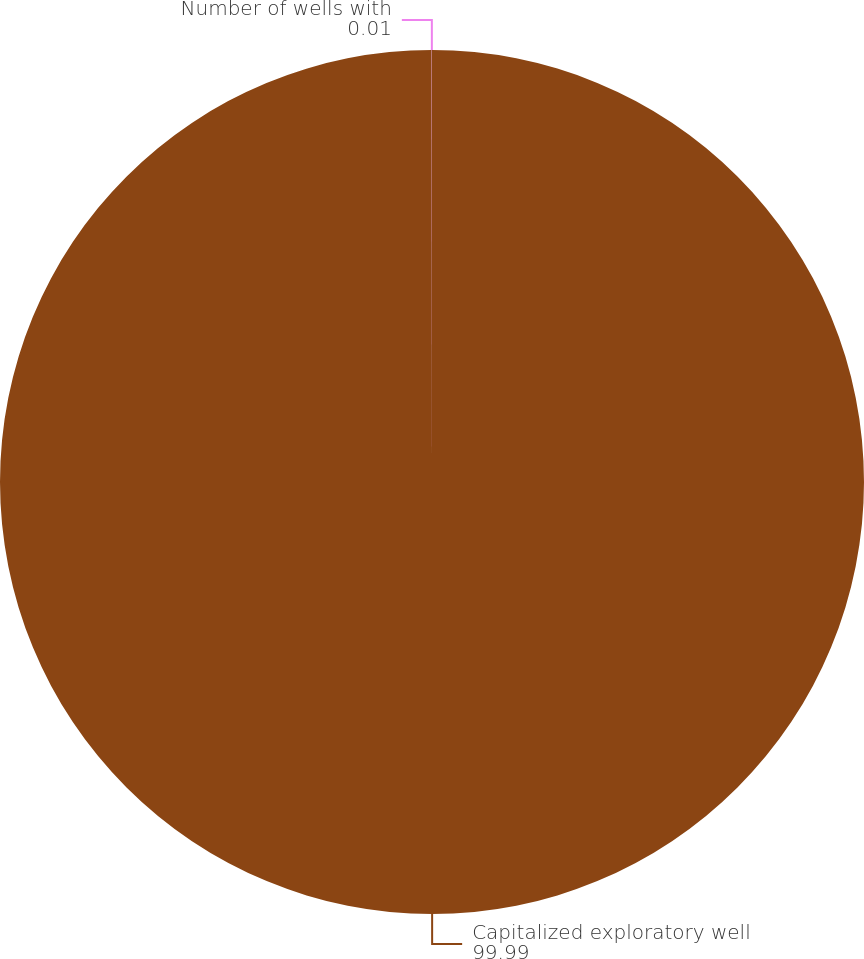Convert chart to OTSL. <chart><loc_0><loc_0><loc_500><loc_500><pie_chart><fcel>Capitalized exploratory well<fcel>Number of wells with<nl><fcel>99.99%<fcel>0.01%<nl></chart> 